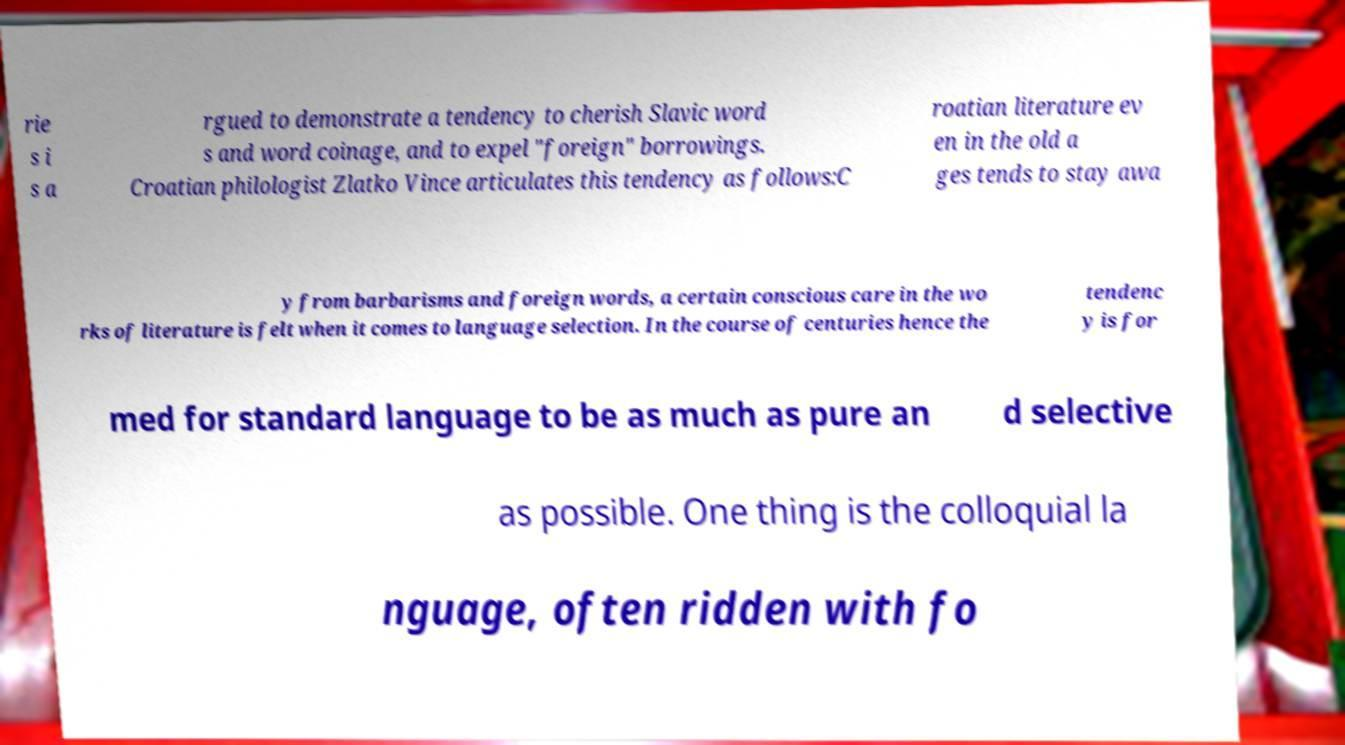Could you assist in decoding the text presented in this image and type it out clearly? rie s i s a rgued to demonstrate a tendency to cherish Slavic word s and word coinage, and to expel "foreign" borrowings. Croatian philologist Zlatko Vince articulates this tendency as follows:C roatian literature ev en in the old a ges tends to stay awa y from barbarisms and foreign words, a certain conscious care in the wo rks of literature is felt when it comes to language selection. In the course of centuries hence the tendenc y is for med for standard language to be as much as pure an d selective as possible. One thing is the colloquial la nguage, often ridden with fo 